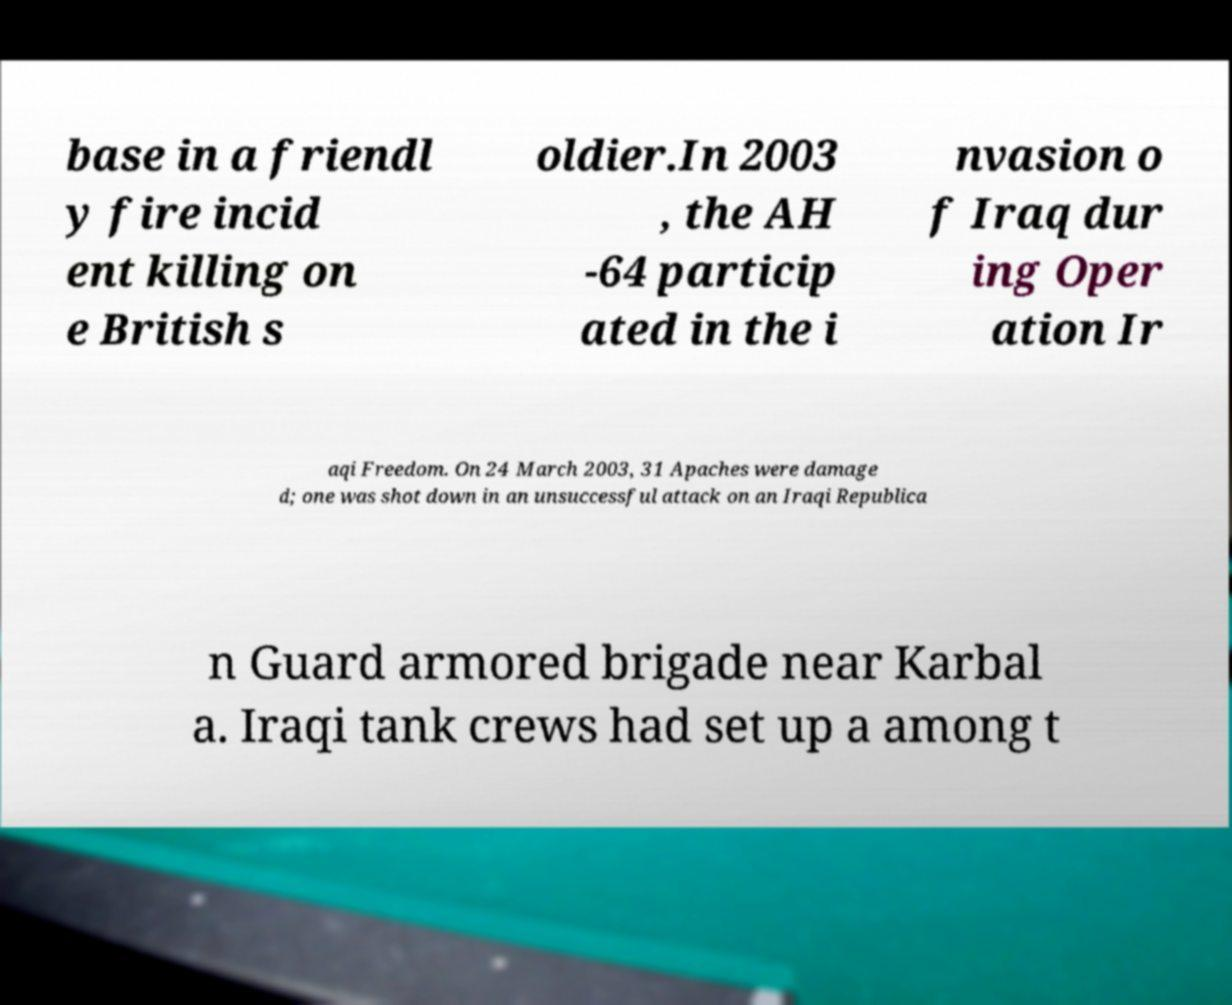Please identify and transcribe the text found in this image. base in a friendl y fire incid ent killing on e British s oldier.In 2003 , the AH -64 particip ated in the i nvasion o f Iraq dur ing Oper ation Ir aqi Freedom. On 24 March 2003, 31 Apaches were damage d; one was shot down in an unsuccessful attack on an Iraqi Republica n Guard armored brigade near Karbal a. Iraqi tank crews had set up a among t 